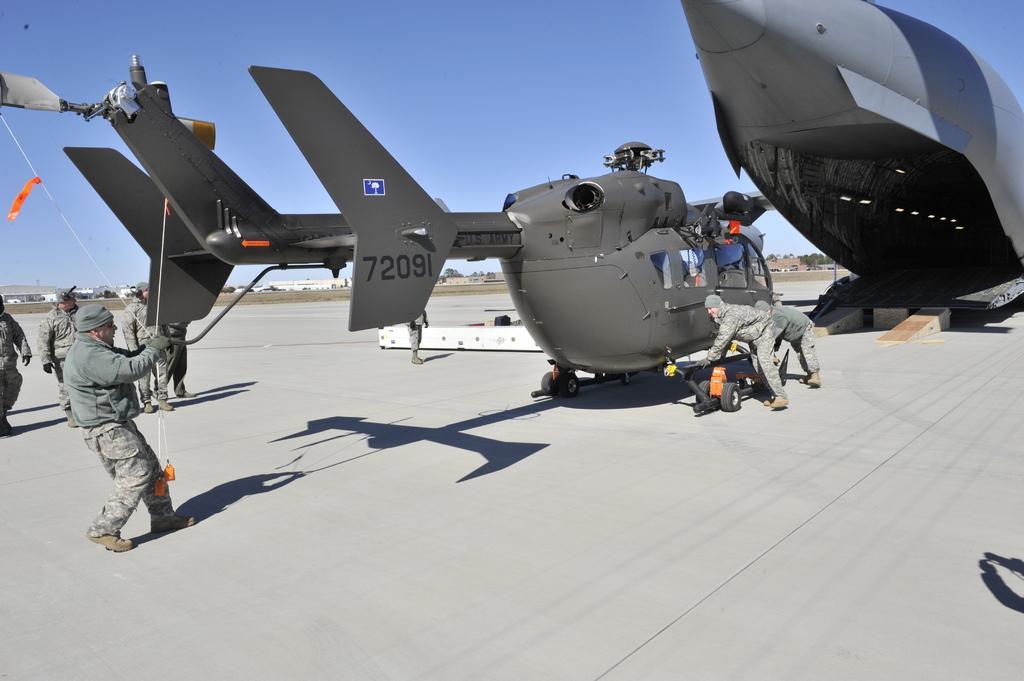Please provide a concise description of this image. In this image we can see two airplanes placed on the ground ,group of persons are wearing uniforms and cap are standing. One person is holding a rope in his hand. In the background,we can see group of buildings and the sky. 